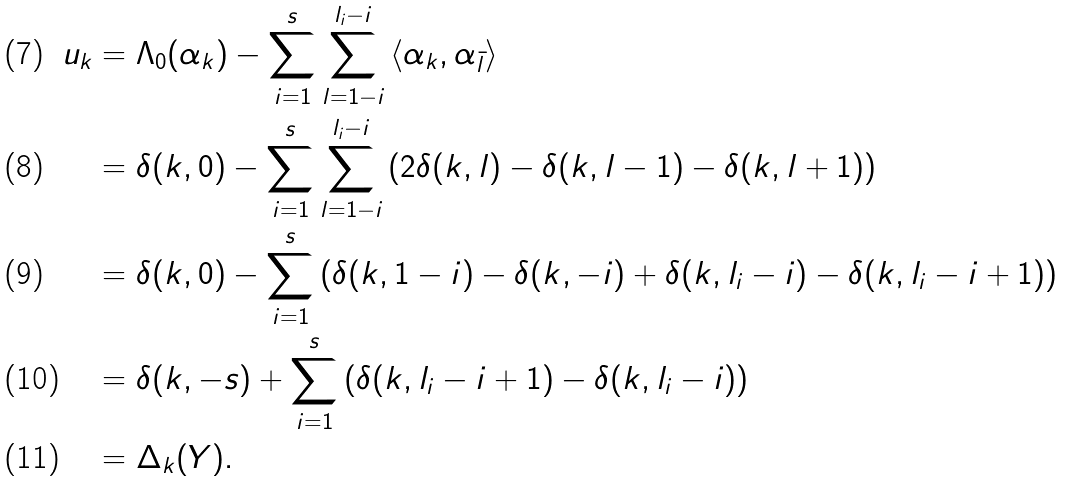Convert formula to latex. <formula><loc_0><loc_0><loc_500><loc_500>u _ { k } & = \Lambda _ { 0 } ( \alpha _ { k } ) - \sum _ { i = 1 } ^ { s } \sum _ { l = 1 - i } ^ { l _ { i } - i } \left < \alpha _ { k } , \alpha _ { \bar { l } } \right > \\ & = \delta ( k , 0 ) - \sum _ { i = 1 } ^ { s } \sum _ { l = 1 - i } ^ { l _ { i } - i } \left ( 2 \delta ( k , l ) - \delta ( k , l - 1 ) - \delta ( k , l + 1 ) \right ) \\ & = \delta ( k , 0 ) - \sum _ { i = 1 } ^ { s } \left ( \delta ( k , 1 - i ) - \delta ( k , - i ) + \delta ( k , l _ { i } - i ) - \delta ( k , l _ { i } - i + 1 ) \right ) \\ & = \delta ( k , - s ) + \sum _ { i = 1 } ^ { s } \left ( \delta ( k , l _ { i } - i + 1 ) - \delta ( k , l _ { i } - i ) \right ) \\ & = \Delta _ { k } ( Y ) .</formula> 